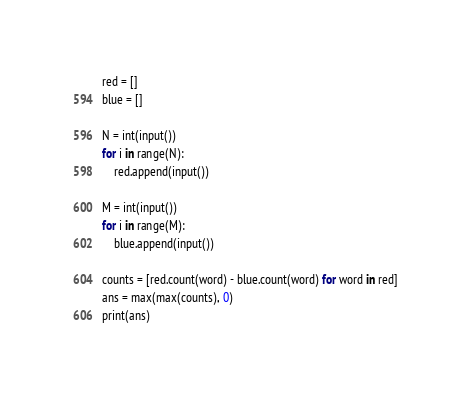<code> <loc_0><loc_0><loc_500><loc_500><_Python_>red = []
blue = []

N = int(input())
for i in range(N):
    red.append(input())
    
M = int(input())
for i in range(M):
    blue.append(input())

counts = [red.count(word) - blue.count(word) for word in red]
ans = max(max(counts), 0)
print(ans)
</code> 